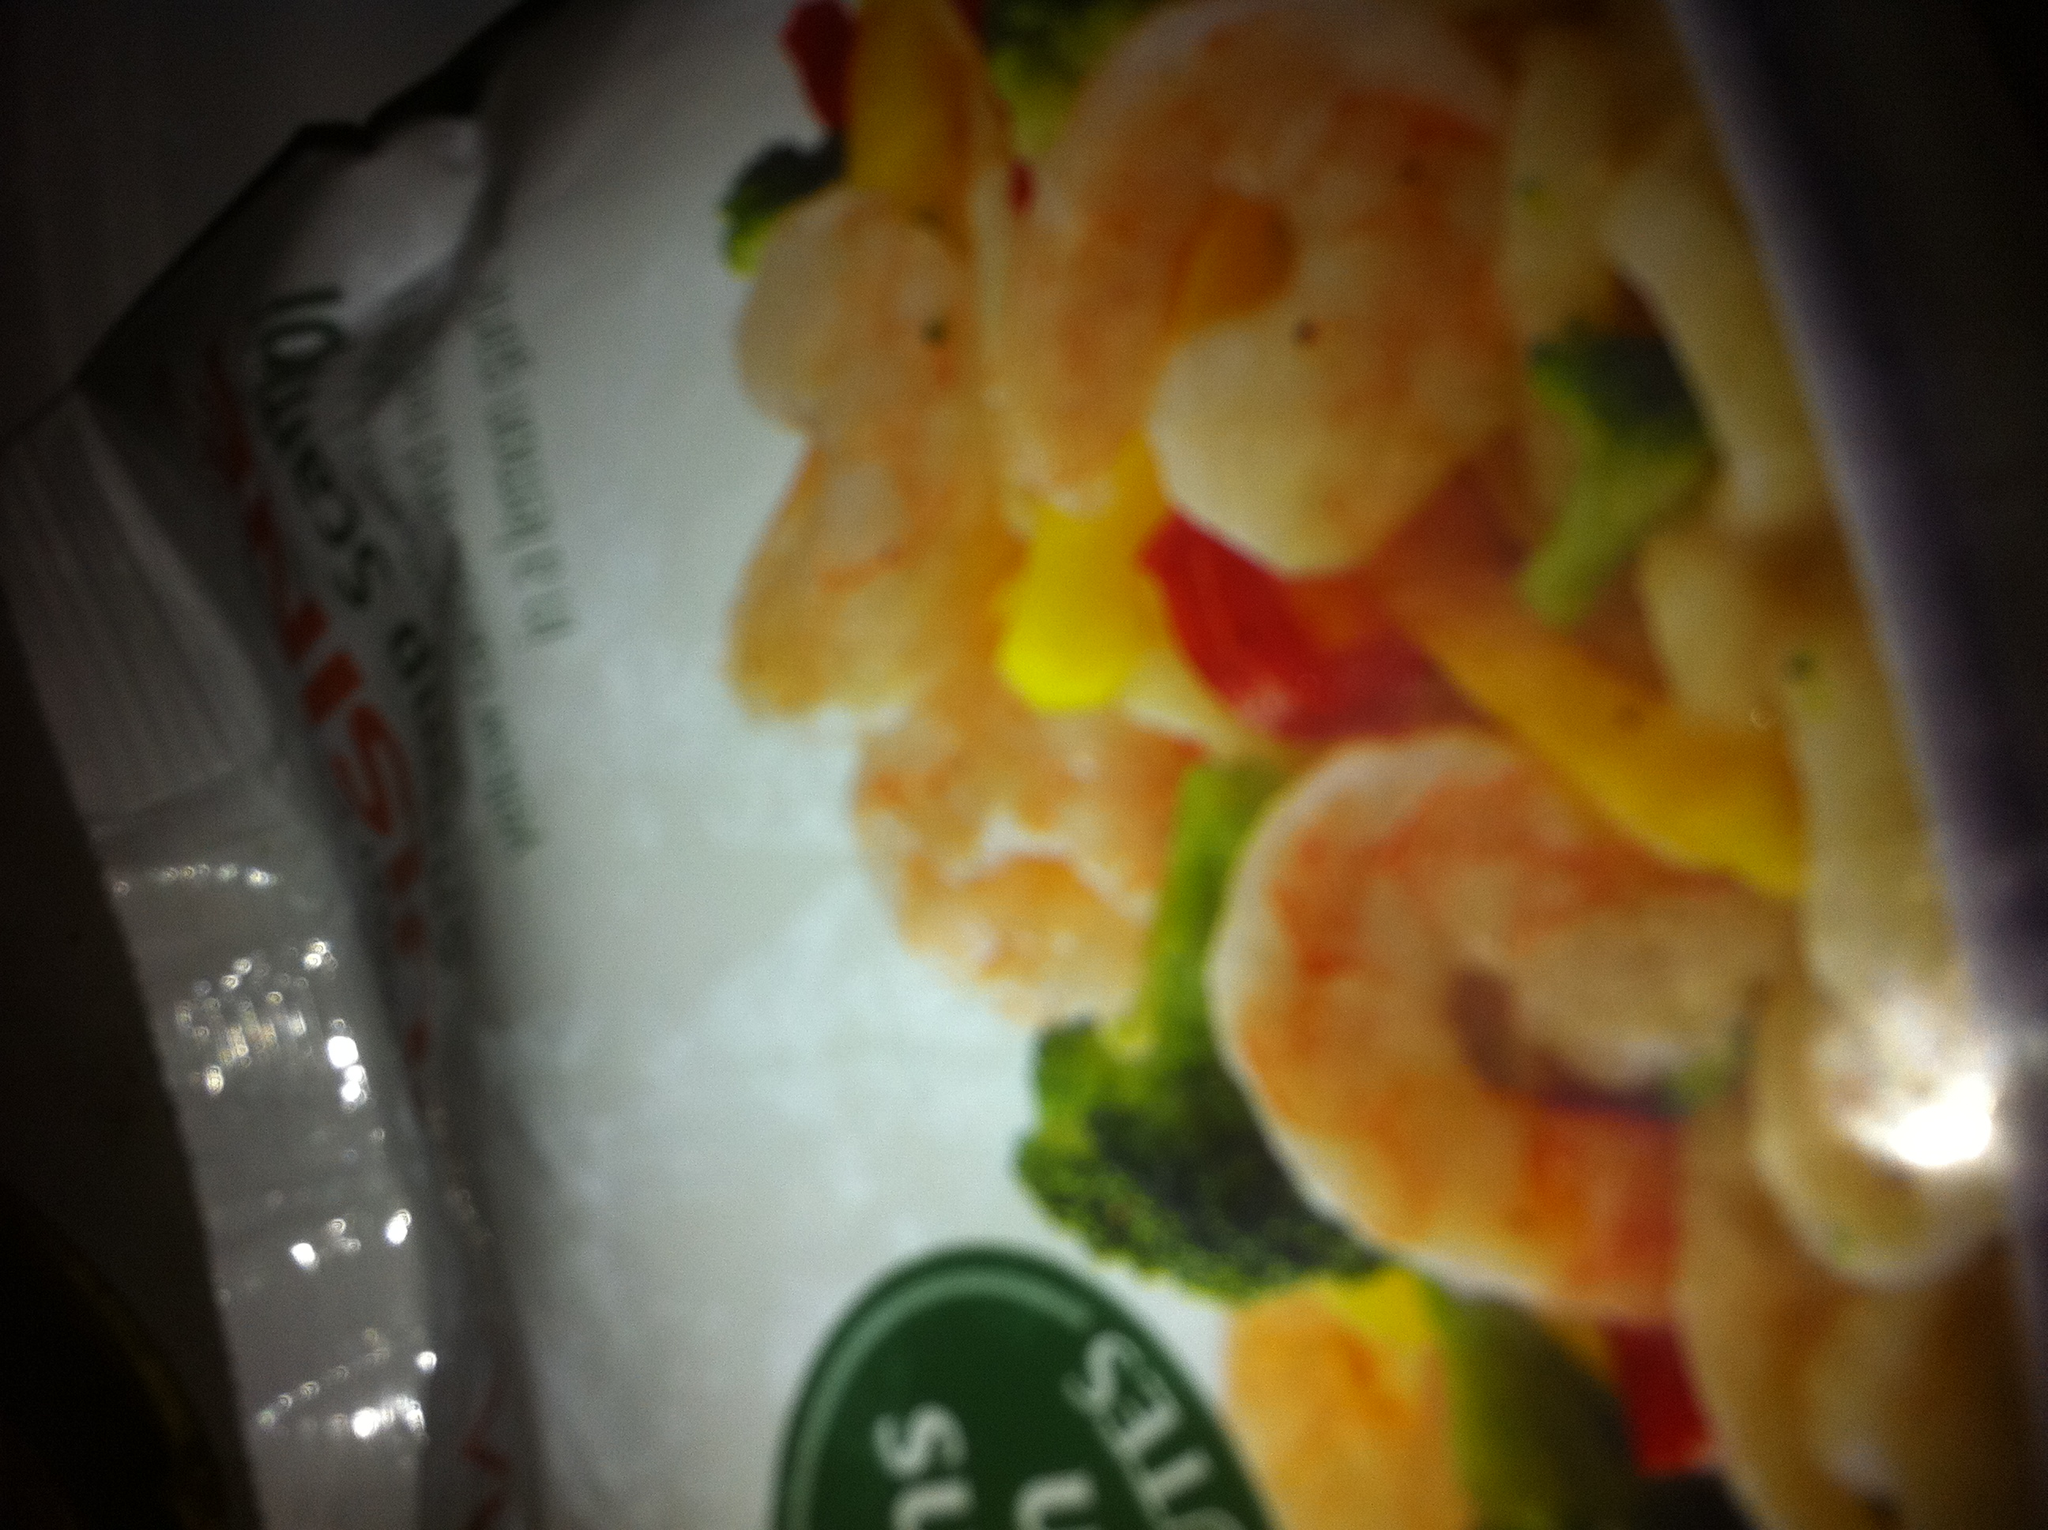Can you tell me more about the preferred cooking method for a dish like this? Certainly! A dish like the one shown, which includes shrimp and vegetables, is typically best when stir-fried. Stir-frying helps retain the crispness and flavors of the vegetables while cooking the shrimp quickly to keep them tender and juicy. It's a quick and healthy cooking method often used in preparing such meals. 